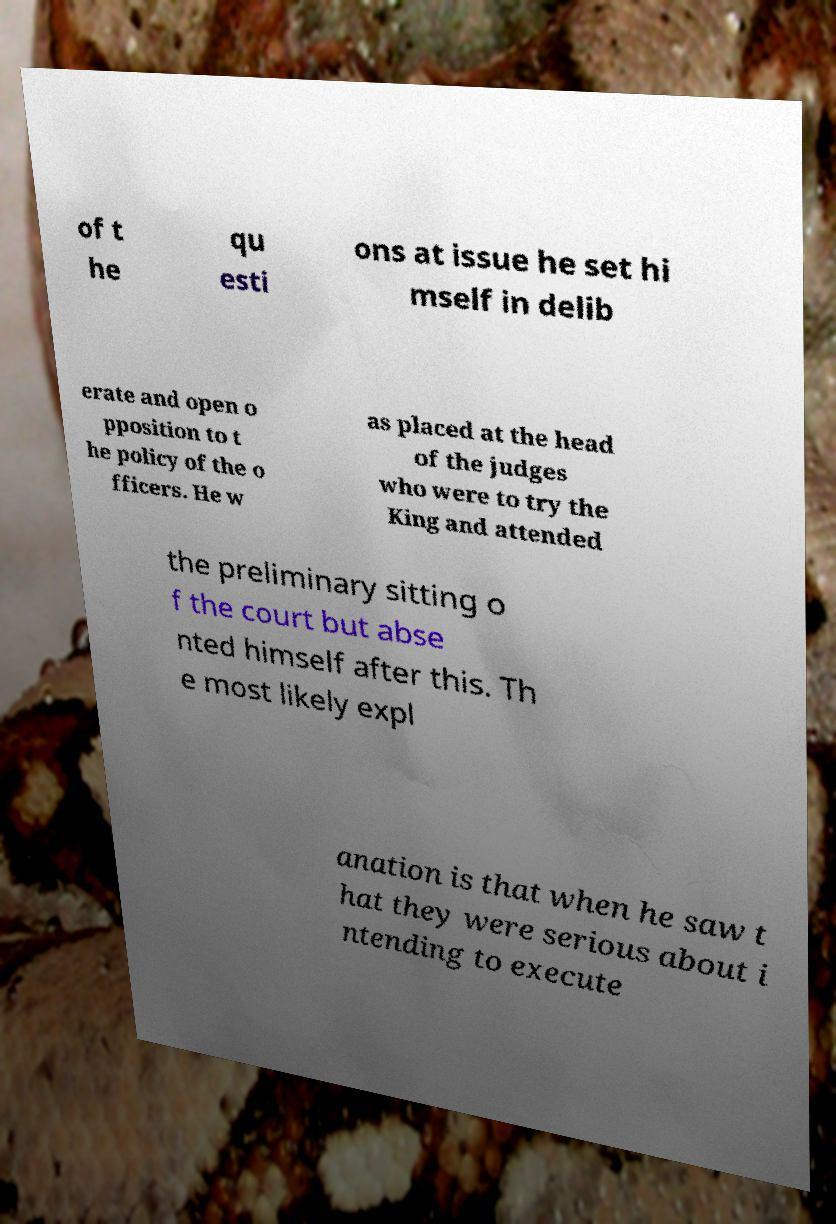There's text embedded in this image that I need extracted. Can you transcribe it verbatim? of t he qu esti ons at issue he set hi mself in delib erate and open o pposition to t he policy of the o fficers. He w as placed at the head of the judges who were to try the King and attended the preliminary sitting o f the court but abse nted himself after this. Th e most likely expl anation is that when he saw t hat they were serious about i ntending to execute 